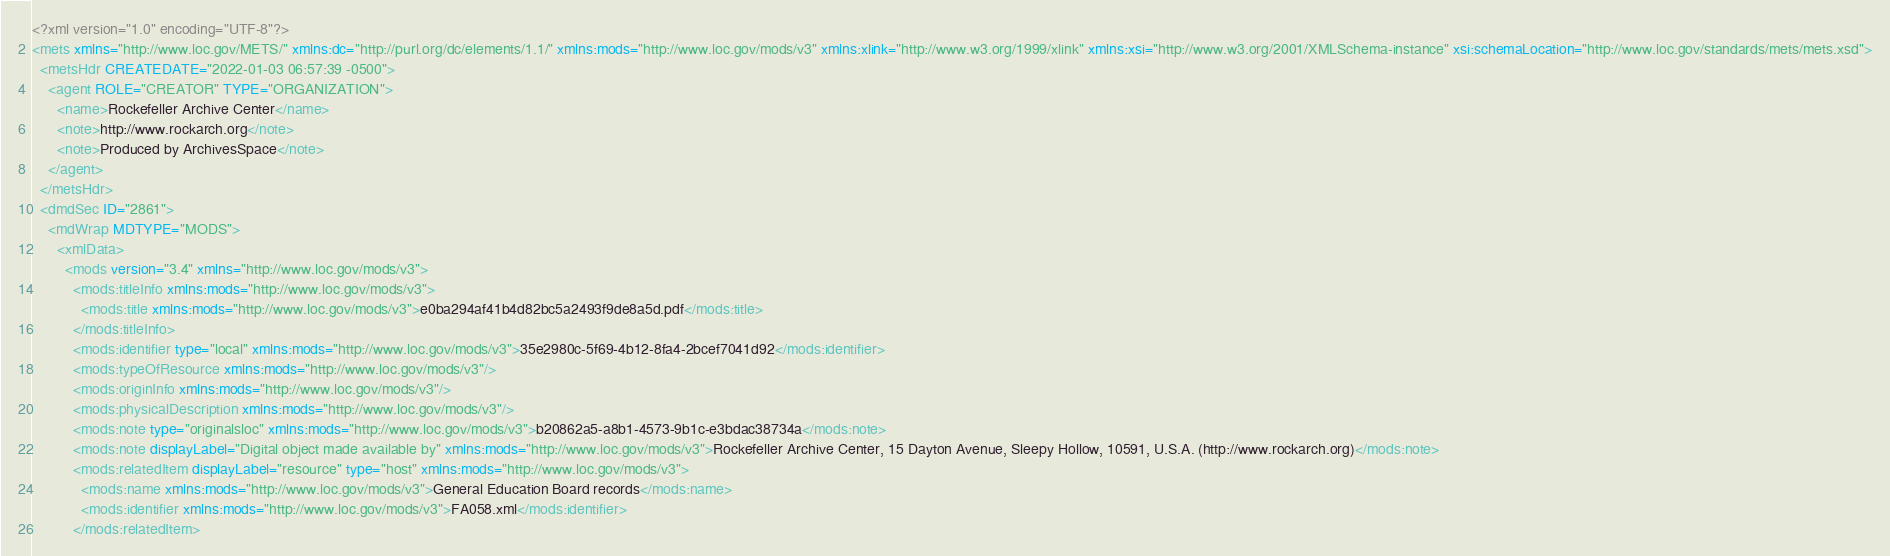Convert code to text. <code><loc_0><loc_0><loc_500><loc_500><_XML_><?xml version="1.0" encoding="UTF-8"?>
<mets xmlns="http://www.loc.gov/METS/" xmlns:dc="http://purl.org/dc/elements/1.1/" xmlns:mods="http://www.loc.gov/mods/v3" xmlns:xlink="http://www.w3.org/1999/xlink" xmlns:xsi="http://www.w3.org/2001/XMLSchema-instance" xsi:schemaLocation="http://www.loc.gov/standards/mets/mets.xsd">
  <metsHdr CREATEDATE="2022-01-03 06:57:39 -0500">
    <agent ROLE="CREATOR" TYPE="ORGANIZATION">
      <name>Rockefeller Archive Center</name>
      <note>http://www.rockarch.org</note>
      <note>Produced by ArchivesSpace</note>
    </agent>
  </metsHdr>
  <dmdSec ID="2861">
    <mdWrap MDTYPE="MODS">
      <xmlData>
        <mods version="3.4" xmlns="http://www.loc.gov/mods/v3">
          <mods:titleInfo xmlns:mods="http://www.loc.gov/mods/v3">
            <mods:title xmlns:mods="http://www.loc.gov/mods/v3">e0ba294af41b4d82bc5a2493f9de8a5d.pdf</mods:title>
          </mods:titleInfo>
          <mods:identifier type="local" xmlns:mods="http://www.loc.gov/mods/v3">35e2980c-5f69-4b12-8fa4-2bcef7041d92</mods:identifier>
          <mods:typeOfResource xmlns:mods="http://www.loc.gov/mods/v3"/>
          <mods:originInfo xmlns:mods="http://www.loc.gov/mods/v3"/>
          <mods:physicalDescription xmlns:mods="http://www.loc.gov/mods/v3"/>
          <mods:note type="originalsloc" xmlns:mods="http://www.loc.gov/mods/v3">b20862a5-a8b1-4573-9b1c-e3bdac38734a</mods:note>
          <mods:note displayLabel="Digital object made available by" xmlns:mods="http://www.loc.gov/mods/v3">Rockefeller Archive Center, 15 Dayton Avenue, Sleepy Hollow, 10591, U.S.A. (http://www.rockarch.org)</mods:note>
          <mods:relatedItem displayLabel="resource" type="host" xmlns:mods="http://www.loc.gov/mods/v3">
            <mods:name xmlns:mods="http://www.loc.gov/mods/v3">General Education Board records</mods:name>
            <mods:identifier xmlns:mods="http://www.loc.gov/mods/v3">FA058.xml</mods:identifier>
          </mods:relatedItem></code> 